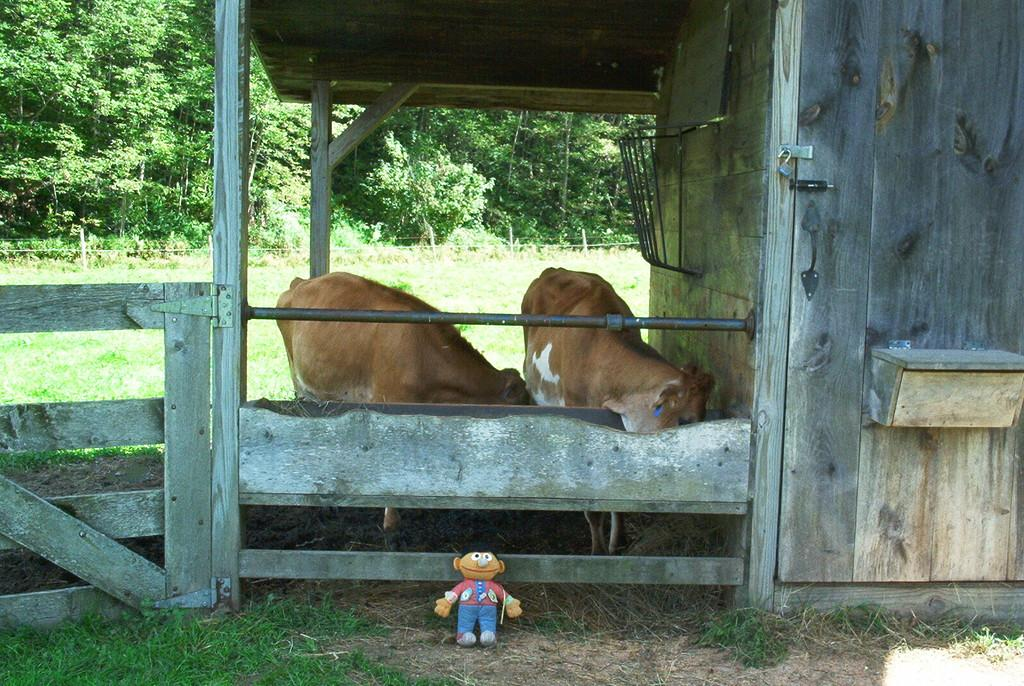What animals are in the center of the image? There are two cows in the center of the image. What object can be seen at the bottom of the image? There is a toy at the bottom of the image. What type of vegetation is visible in the background of the image? There are trees in the background of the image. What type of fencing is present in the image? There is a wooden fencing in the image. Does the man in the image express any feelings of hate towards the cows? There is no man present in the image, so it is not possible to determine any feelings of hate towards the cows. 